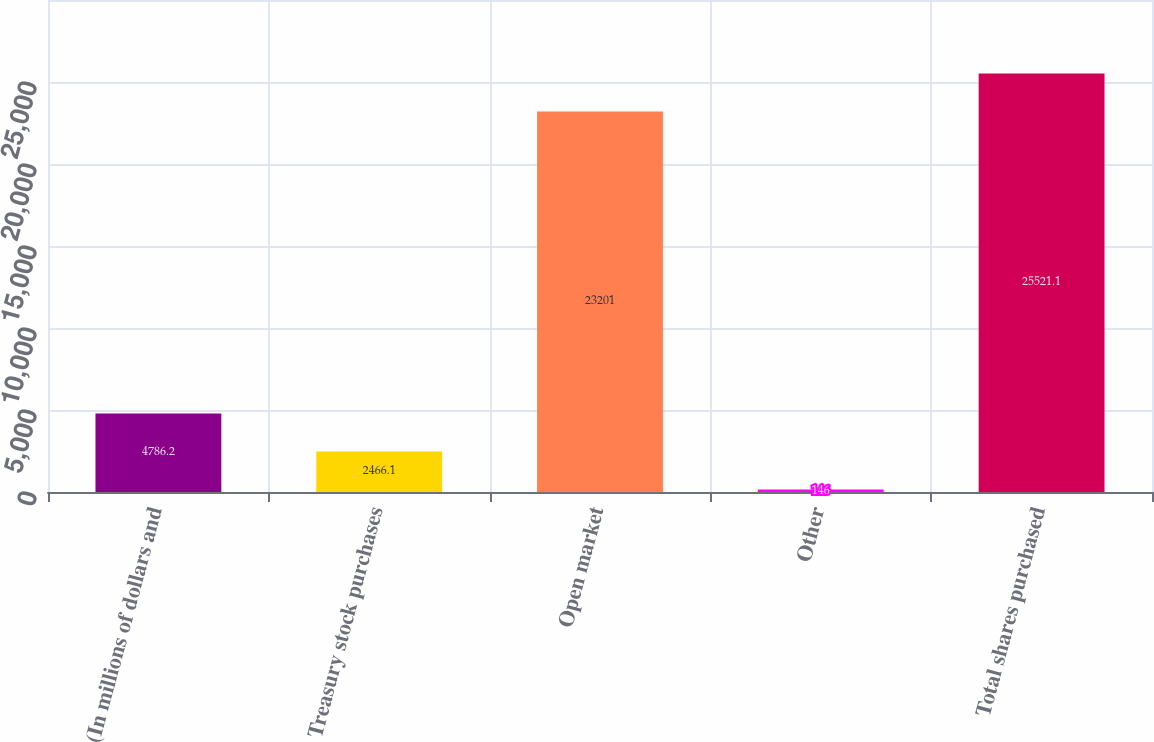Convert chart to OTSL. <chart><loc_0><loc_0><loc_500><loc_500><bar_chart><fcel>(In millions of dollars and<fcel>Treasury stock purchases<fcel>Open market<fcel>Other<fcel>Total shares purchased<nl><fcel>4786.2<fcel>2466.1<fcel>23201<fcel>146<fcel>25521.1<nl></chart> 